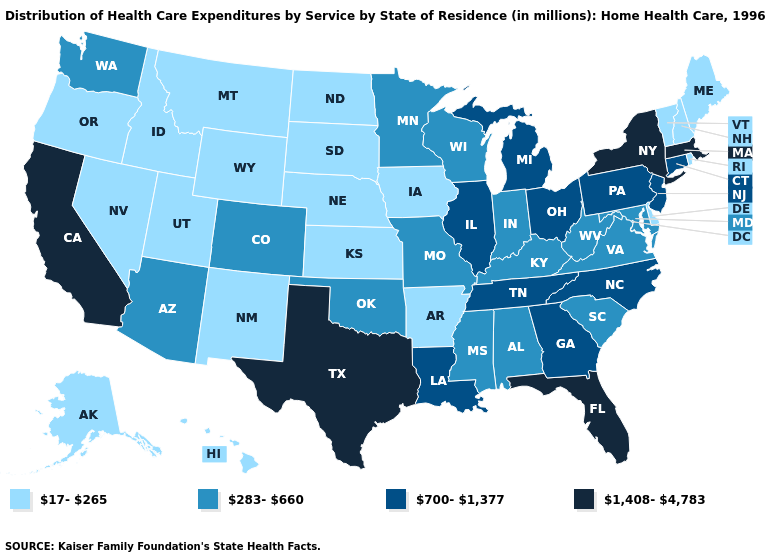Is the legend a continuous bar?
Quick response, please. No. Does Nebraska have the same value as Maine?
Answer briefly. Yes. What is the highest value in states that border North Carolina?
Keep it brief. 700-1,377. Does Nebraska have a lower value than New Mexico?
Concise answer only. No. Name the states that have a value in the range 283-660?
Keep it brief. Alabama, Arizona, Colorado, Indiana, Kentucky, Maryland, Minnesota, Mississippi, Missouri, Oklahoma, South Carolina, Virginia, Washington, West Virginia, Wisconsin. Name the states that have a value in the range 1,408-4,783?
Short answer required. California, Florida, Massachusetts, New York, Texas. Name the states that have a value in the range 1,408-4,783?
Answer briefly. California, Florida, Massachusetts, New York, Texas. Does Nebraska have the same value as Illinois?
Be succinct. No. What is the value of West Virginia?
Be succinct. 283-660. What is the lowest value in the USA?
Answer briefly. 17-265. Name the states that have a value in the range 17-265?
Be succinct. Alaska, Arkansas, Delaware, Hawaii, Idaho, Iowa, Kansas, Maine, Montana, Nebraska, Nevada, New Hampshire, New Mexico, North Dakota, Oregon, Rhode Island, South Dakota, Utah, Vermont, Wyoming. What is the value of Iowa?
Write a very short answer. 17-265. Does Arizona have the same value as Wisconsin?
Quick response, please. Yes. What is the value of Illinois?
Answer briefly. 700-1,377. What is the value of Washington?
Answer briefly. 283-660. 